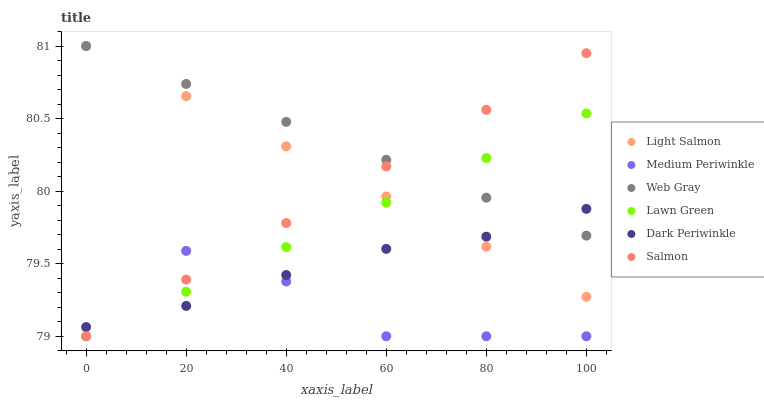Does Medium Periwinkle have the minimum area under the curve?
Answer yes or no. Yes. Does Web Gray have the maximum area under the curve?
Answer yes or no. Yes. Does Light Salmon have the minimum area under the curve?
Answer yes or no. No. Does Light Salmon have the maximum area under the curve?
Answer yes or no. No. Is Light Salmon the smoothest?
Answer yes or no. Yes. Is Medium Periwinkle the roughest?
Answer yes or no. Yes. Is Salmon the smoothest?
Answer yes or no. No. Is Salmon the roughest?
Answer yes or no. No. Does Lawn Green have the lowest value?
Answer yes or no. Yes. Does Light Salmon have the lowest value?
Answer yes or no. No. Does Web Gray have the highest value?
Answer yes or no. Yes. Does Salmon have the highest value?
Answer yes or no. No. Is Medium Periwinkle less than Light Salmon?
Answer yes or no. Yes. Is Web Gray greater than Medium Periwinkle?
Answer yes or no. Yes. Does Light Salmon intersect Salmon?
Answer yes or no. Yes. Is Light Salmon less than Salmon?
Answer yes or no. No. Is Light Salmon greater than Salmon?
Answer yes or no. No. Does Medium Periwinkle intersect Light Salmon?
Answer yes or no. No. 